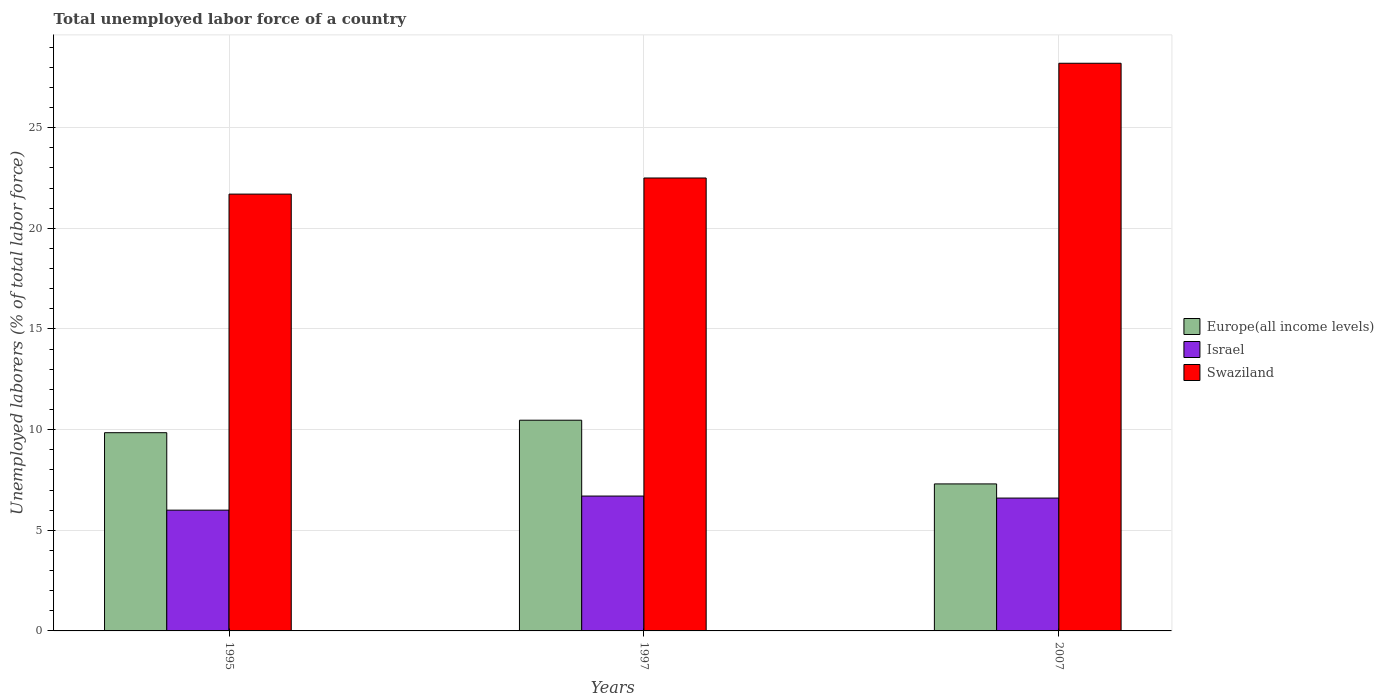How many groups of bars are there?
Give a very brief answer. 3. Are the number of bars per tick equal to the number of legend labels?
Offer a very short reply. Yes. Are the number of bars on each tick of the X-axis equal?
Provide a short and direct response. Yes. How many bars are there on the 1st tick from the left?
Offer a very short reply. 3. How many bars are there on the 3rd tick from the right?
Provide a succinct answer. 3. What is the total unemployed labor force in Swaziland in 1995?
Offer a terse response. 21.7. Across all years, what is the maximum total unemployed labor force in Europe(all income levels)?
Your response must be concise. 10.47. Across all years, what is the minimum total unemployed labor force in Swaziland?
Ensure brevity in your answer.  21.7. What is the total total unemployed labor force in Swaziland in the graph?
Give a very brief answer. 72.4. What is the difference between the total unemployed labor force in Europe(all income levels) in 1995 and that in 1997?
Provide a succinct answer. -0.62. What is the difference between the total unemployed labor force in Europe(all income levels) in 2007 and the total unemployed labor force in Israel in 1997?
Your response must be concise. 0.6. What is the average total unemployed labor force in Israel per year?
Offer a very short reply. 6.43. In the year 1995, what is the difference between the total unemployed labor force in Europe(all income levels) and total unemployed labor force in Swaziland?
Offer a very short reply. -11.85. In how many years, is the total unemployed labor force in Swaziland greater than 15 %?
Offer a very short reply. 3. What is the ratio of the total unemployed labor force in Europe(all income levels) in 1997 to that in 2007?
Give a very brief answer. 1.43. What is the difference between the highest and the second highest total unemployed labor force in Europe(all income levels)?
Make the answer very short. 0.62. What is the difference between the highest and the lowest total unemployed labor force in Europe(all income levels)?
Offer a terse response. 3.17. Is the sum of the total unemployed labor force in Europe(all income levels) in 1997 and 2007 greater than the maximum total unemployed labor force in Swaziland across all years?
Offer a very short reply. No. What does the 1st bar from the left in 2007 represents?
Your answer should be very brief. Europe(all income levels). What does the 1st bar from the right in 2007 represents?
Your answer should be very brief. Swaziland. How many years are there in the graph?
Keep it short and to the point. 3. What is the difference between two consecutive major ticks on the Y-axis?
Offer a very short reply. 5. Does the graph contain grids?
Your answer should be compact. Yes. How many legend labels are there?
Your answer should be very brief. 3. How are the legend labels stacked?
Provide a short and direct response. Vertical. What is the title of the graph?
Your answer should be compact. Total unemployed labor force of a country. What is the label or title of the X-axis?
Keep it short and to the point. Years. What is the label or title of the Y-axis?
Offer a very short reply. Unemployed laborers (% of total labor force). What is the Unemployed laborers (% of total labor force) in Europe(all income levels) in 1995?
Keep it short and to the point. 9.85. What is the Unemployed laborers (% of total labor force) in Israel in 1995?
Offer a very short reply. 6. What is the Unemployed laborers (% of total labor force) of Swaziland in 1995?
Provide a short and direct response. 21.7. What is the Unemployed laborers (% of total labor force) in Europe(all income levels) in 1997?
Your response must be concise. 10.47. What is the Unemployed laborers (% of total labor force) in Israel in 1997?
Make the answer very short. 6.7. What is the Unemployed laborers (% of total labor force) of Swaziland in 1997?
Your answer should be very brief. 22.5. What is the Unemployed laborers (% of total labor force) in Europe(all income levels) in 2007?
Give a very brief answer. 7.3. What is the Unemployed laborers (% of total labor force) of Israel in 2007?
Your answer should be compact. 6.6. What is the Unemployed laborers (% of total labor force) in Swaziland in 2007?
Provide a short and direct response. 28.2. Across all years, what is the maximum Unemployed laborers (% of total labor force) of Europe(all income levels)?
Ensure brevity in your answer.  10.47. Across all years, what is the maximum Unemployed laborers (% of total labor force) in Israel?
Offer a very short reply. 6.7. Across all years, what is the maximum Unemployed laborers (% of total labor force) of Swaziland?
Your answer should be very brief. 28.2. Across all years, what is the minimum Unemployed laborers (% of total labor force) of Europe(all income levels)?
Give a very brief answer. 7.3. Across all years, what is the minimum Unemployed laborers (% of total labor force) in Israel?
Provide a succinct answer. 6. Across all years, what is the minimum Unemployed laborers (% of total labor force) in Swaziland?
Make the answer very short. 21.7. What is the total Unemployed laborers (% of total labor force) of Europe(all income levels) in the graph?
Your response must be concise. 27.62. What is the total Unemployed laborers (% of total labor force) of Israel in the graph?
Ensure brevity in your answer.  19.3. What is the total Unemployed laborers (% of total labor force) in Swaziland in the graph?
Provide a succinct answer. 72.4. What is the difference between the Unemployed laborers (% of total labor force) in Europe(all income levels) in 1995 and that in 1997?
Provide a short and direct response. -0.62. What is the difference between the Unemployed laborers (% of total labor force) in Israel in 1995 and that in 1997?
Your answer should be compact. -0.7. What is the difference between the Unemployed laborers (% of total labor force) of Swaziland in 1995 and that in 1997?
Ensure brevity in your answer.  -0.8. What is the difference between the Unemployed laborers (% of total labor force) in Europe(all income levels) in 1995 and that in 2007?
Your answer should be very brief. 2.54. What is the difference between the Unemployed laborers (% of total labor force) in Swaziland in 1995 and that in 2007?
Provide a short and direct response. -6.5. What is the difference between the Unemployed laborers (% of total labor force) of Europe(all income levels) in 1997 and that in 2007?
Give a very brief answer. 3.17. What is the difference between the Unemployed laborers (% of total labor force) in Europe(all income levels) in 1995 and the Unemployed laborers (% of total labor force) in Israel in 1997?
Ensure brevity in your answer.  3.15. What is the difference between the Unemployed laborers (% of total labor force) in Europe(all income levels) in 1995 and the Unemployed laborers (% of total labor force) in Swaziland in 1997?
Your answer should be very brief. -12.65. What is the difference between the Unemployed laborers (% of total labor force) in Israel in 1995 and the Unemployed laborers (% of total labor force) in Swaziland in 1997?
Your answer should be compact. -16.5. What is the difference between the Unemployed laborers (% of total labor force) of Europe(all income levels) in 1995 and the Unemployed laborers (% of total labor force) of Israel in 2007?
Offer a terse response. 3.25. What is the difference between the Unemployed laborers (% of total labor force) of Europe(all income levels) in 1995 and the Unemployed laborers (% of total labor force) of Swaziland in 2007?
Make the answer very short. -18.35. What is the difference between the Unemployed laborers (% of total labor force) of Israel in 1995 and the Unemployed laborers (% of total labor force) of Swaziland in 2007?
Give a very brief answer. -22.2. What is the difference between the Unemployed laborers (% of total labor force) in Europe(all income levels) in 1997 and the Unemployed laborers (% of total labor force) in Israel in 2007?
Keep it short and to the point. 3.87. What is the difference between the Unemployed laborers (% of total labor force) in Europe(all income levels) in 1997 and the Unemployed laborers (% of total labor force) in Swaziland in 2007?
Make the answer very short. -17.73. What is the difference between the Unemployed laborers (% of total labor force) in Israel in 1997 and the Unemployed laborers (% of total labor force) in Swaziland in 2007?
Provide a succinct answer. -21.5. What is the average Unemployed laborers (% of total labor force) of Europe(all income levels) per year?
Ensure brevity in your answer.  9.21. What is the average Unemployed laborers (% of total labor force) in Israel per year?
Your answer should be compact. 6.43. What is the average Unemployed laborers (% of total labor force) of Swaziland per year?
Offer a very short reply. 24.13. In the year 1995, what is the difference between the Unemployed laborers (% of total labor force) of Europe(all income levels) and Unemployed laborers (% of total labor force) of Israel?
Give a very brief answer. 3.85. In the year 1995, what is the difference between the Unemployed laborers (% of total labor force) of Europe(all income levels) and Unemployed laborers (% of total labor force) of Swaziland?
Make the answer very short. -11.85. In the year 1995, what is the difference between the Unemployed laborers (% of total labor force) of Israel and Unemployed laborers (% of total labor force) of Swaziland?
Your response must be concise. -15.7. In the year 1997, what is the difference between the Unemployed laborers (% of total labor force) in Europe(all income levels) and Unemployed laborers (% of total labor force) in Israel?
Offer a terse response. 3.77. In the year 1997, what is the difference between the Unemployed laborers (% of total labor force) of Europe(all income levels) and Unemployed laborers (% of total labor force) of Swaziland?
Offer a very short reply. -12.03. In the year 1997, what is the difference between the Unemployed laborers (% of total labor force) in Israel and Unemployed laborers (% of total labor force) in Swaziland?
Provide a succinct answer. -15.8. In the year 2007, what is the difference between the Unemployed laborers (% of total labor force) in Europe(all income levels) and Unemployed laborers (% of total labor force) in Israel?
Ensure brevity in your answer.  0.7. In the year 2007, what is the difference between the Unemployed laborers (% of total labor force) in Europe(all income levels) and Unemployed laborers (% of total labor force) in Swaziland?
Your response must be concise. -20.9. In the year 2007, what is the difference between the Unemployed laborers (% of total labor force) of Israel and Unemployed laborers (% of total labor force) of Swaziland?
Provide a succinct answer. -21.6. What is the ratio of the Unemployed laborers (% of total labor force) of Europe(all income levels) in 1995 to that in 1997?
Offer a very short reply. 0.94. What is the ratio of the Unemployed laborers (% of total labor force) in Israel in 1995 to that in 1997?
Offer a very short reply. 0.9. What is the ratio of the Unemployed laborers (% of total labor force) in Swaziland in 1995 to that in 1997?
Your response must be concise. 0.96. What is the ratio of the Unemployed laborers (% of total labor force) of Europe(all income levels) in 1995 to that in 2007?
Offer a very short reply. 1.35. What is the ratio of the Unemployed laborers (% of total labor force) of Israel in 1995 to that in 2007?
Keep it short and to the point. 0.91. What is the ratio of the Unemployed laborers (% of total labor force) in Swaziland in 1995 to that in 2007?
Provide a succinct answer. 0.77. What is the ratio of the Unemployed laborers (% of total labor force) of Europe(all income levels) in 1997 to that in 2007?
Ensure brevity in your answer.  1.43. What is the ratio of the Unemployed laborers (% of total labor force) in Israel in 1997 to that in 2007?
Your answer should be very brief. 1.02. What is the ratio of the Unemployed laborers (% of total labor force) in Swaziland in 1997 to that in 2007?
Provide a short and direct response. 0.8. What is the difference between the highest and the second highest Unemployed laborers (% of total labor force) of Europe(all income levels)?
Offer a terse response. 0.62. What is the difference between the highest and the lowest Unemployed laborers (% of total labor force) of Europe(all income levels)?
Your answer should be very brief. 3.17. What is the difference between the highest and the lowest Unemployed laborers (% of total labor force) in Swaziland?
Provide a short and direct response. 6.5. 